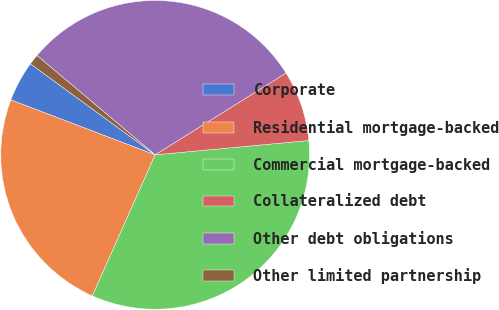<chart> <loc_0><loc_0><loc_500><loc_500><pie_chart><fcel>Corporate<fcel>Residential mortgage-backed<fcel>Commercial mortgage-backed<fcel>Collateralized debt<fcel>Other debt obligations<fcel>Other limited partnership<nl><fcel>4.25%<fcel>24.13%<fcel>33.15%<fcel>7.41%<fcel>29.99%<fcel>1.09%<nl></chart> 